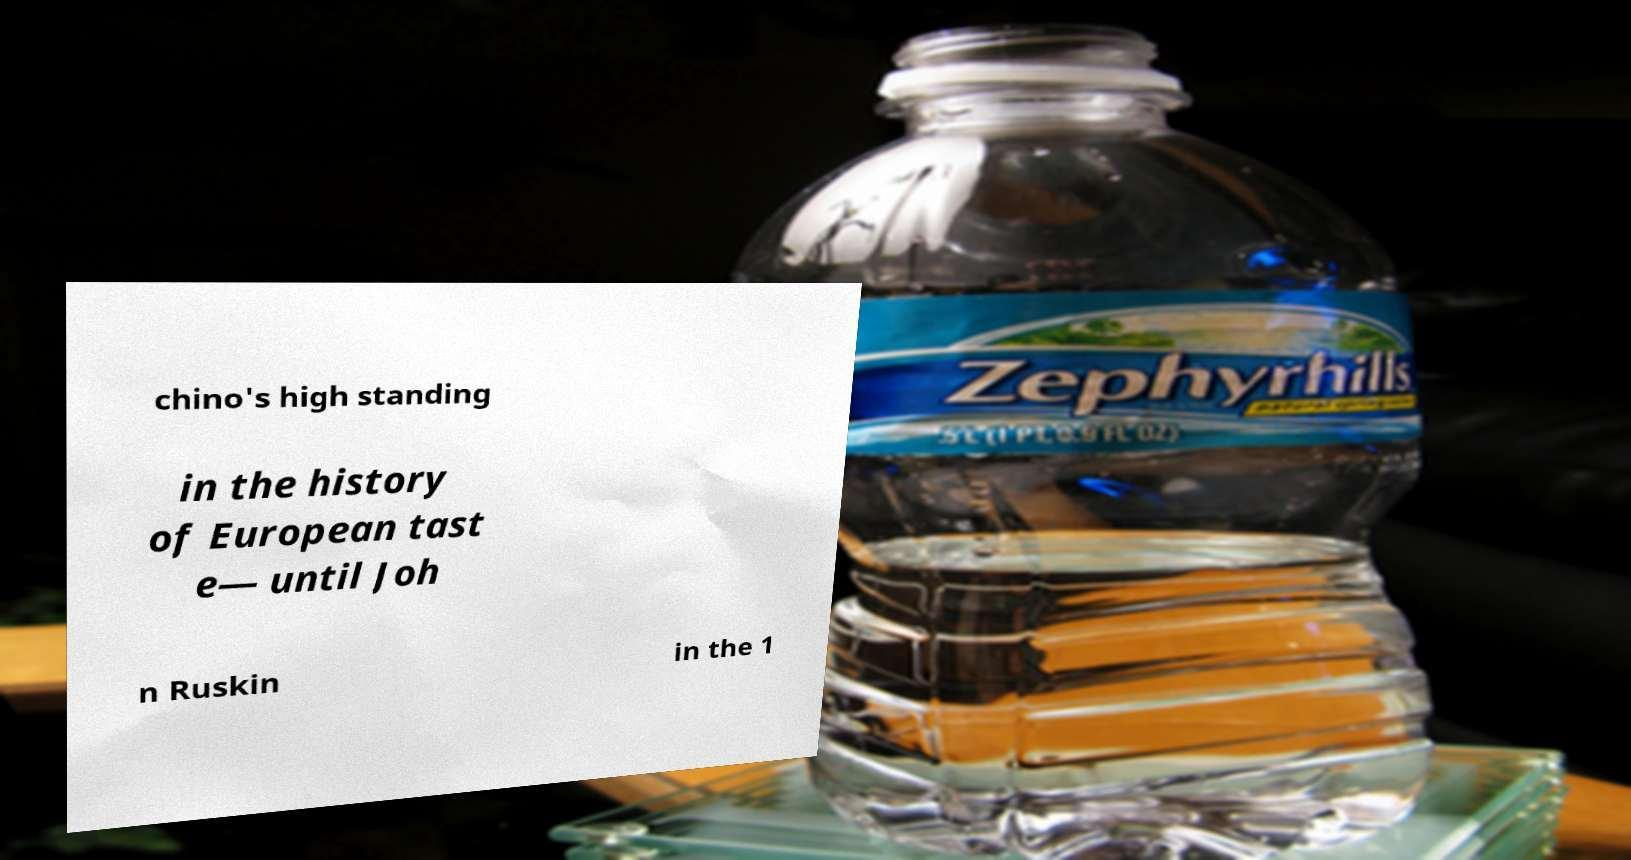For documentation purposes, I need the text within this image transcribed. Could you provide that? chino's high standing in the history of European tast e— until Joh n Ruskin in the 1 